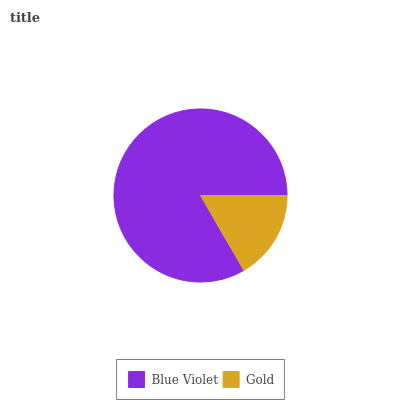Is Gold the minimum?
Answer yes or no. Yes. Is Blue Violet the maximum?
Answer yes or no. Yes. Is Gold the maximum?
Answer yes or no. No. Is Blue Violet greater than Gold?
Answer yes or no. Yes. Is Gold less than Blue Violet?
Answer yes or no. Yes. Is Gold greater than Blue Violet?
Answer yes or no. No. Is Blue Violet less than Gold?
Answer yes or no. No. Is Blue Violet the high median?
Answer yes or no. Yes. Is Gold the low median?
Answer yes or no. Yes. Is Gold the high median?
Answer yes or no. No. Is Blue Violet the low median?
Answer yes or no. No. 